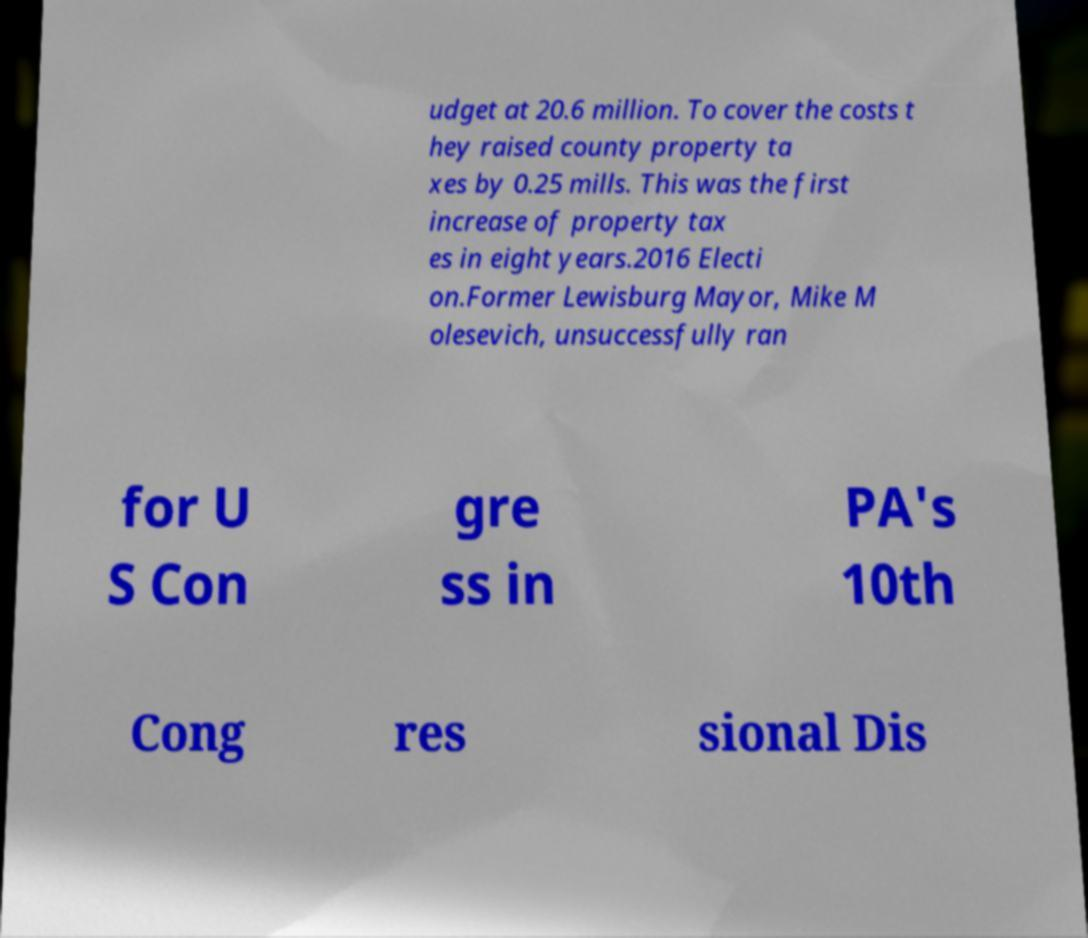What messages or text are displayed in this image? I need them in a readable, typed format. udget at 20.6 million. To cover the costs t hey raised county property ta xes by 0.25 mills. This was the first increase of property tax es in eight years.2016 Electi on.Former Lewisburg Mayor, Mike M olesevich, unsuccessfully ran for U S Con gre ss in PA's 10th Cong res sional Dis 